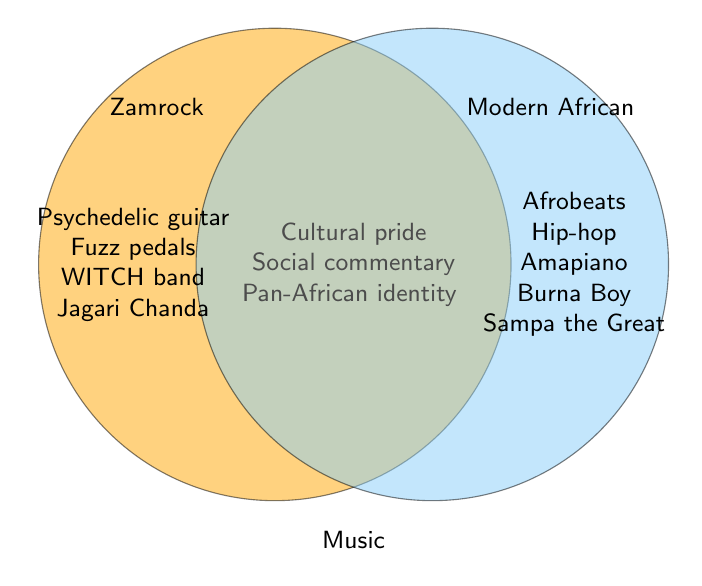What theme is unique to Zamrock music but not found in modern African music? By looking at the left part of the Venn diagram where Zamrock music is represented, we see elements like "Psychedelic guitar," "Fuzz pedals," "WITCH band," and "Jagari Chanda" which do not appear in the right part devoted to modern African music.
Answer: Psychedelic guitar, Fuzz pedals, WITCH band, Jagari Chanda Which two artists are specifically associated with modern African music? By examining the right part of the Venn diagram, dedicated to modern African music, we can see that "Burna Boy" and "Sampa the Great" are listed as specific artists for this genre.
Answer: Burna Boy, Sampa the Great Name one theme that overlaps between Zamrock and modern African music. Looking at the overlapping section in the middle of the Venn diagram, which includes themes common to both, we see "Cultural pride," "Social commentary," and "Pan-African identity." Any one of these can be mentioned.
Answer: Cultural pride, Social commentary, Pan-African identity What common element does modern African music contain that is not present in Zamrock? Looking at the right side of the Venn diagram which represents modern African music, elements like "Afrobeats," "Hip-hop," "Amapiano," "Burna Boy," and "Sampa the Great" do not appear in the left Venn section dedicated to Zamrock.
Answer: Afrobeats, Hip-hop, Amapiano Which musical element associated with Modern African music is related to production techniques? From the right part of the Venn diagram, the element "Electronic production" clearly indicates a production technique related to modern African music.
Answer: Electronic production 